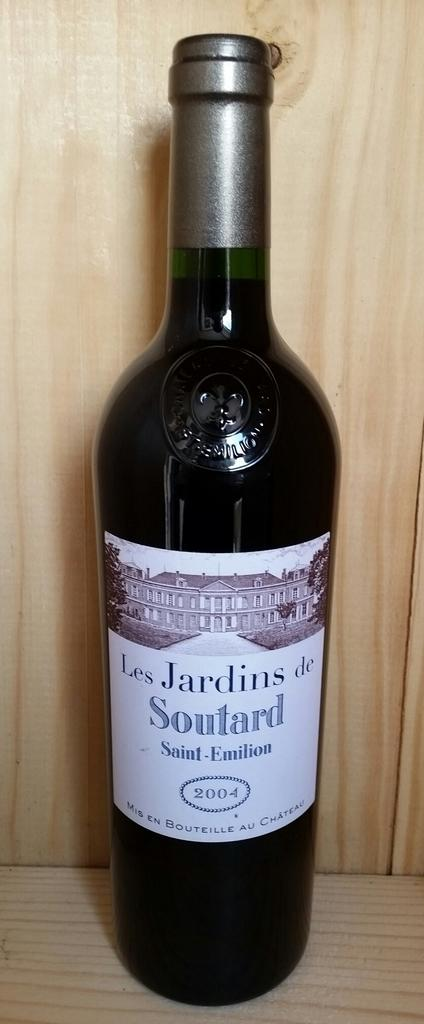Provide a one-sentence caption for the provided image. A bottle of Les Jardins Soutard wine is displayed against a wooden backdrop. 